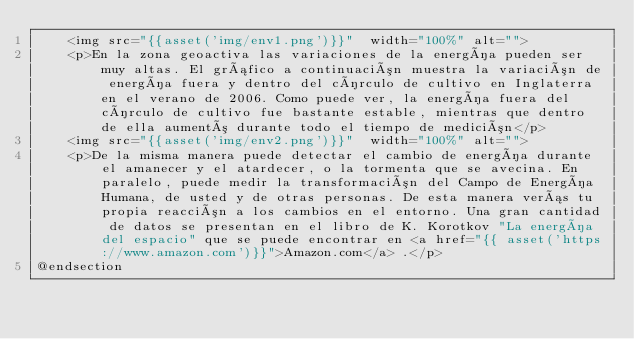Convert code to text. <code><loc_0><loc_0><loc_500><loc_500><_PHP_>    <img src="{{asset('img/env1.png')}}"  width="100%" alt="">
    <p>En la zona geoactiva las variaciones de la energía pueden ser muy altas. El gráfico a continuación muestra la variación de energía fuera y dentro del círculo de cultivo en Inglaterra en el verano de 2006. Como puede ver, la energía fuera del círculo de cultivo fue bastante estable, mientras que dentro de ella aumentó durante todo el tiempo de medición</p>
    <img src="{{asset('img/env2.png')}}"  width="100%" alt="">
    <p>De la misma manera puede detectar el cambio de energía durante el amanecer y el atardecer, o la tormenta que se avecina. En paralelo, puede medir la transformación del Campo de Energía Humana, de usted y de otras personas. De esta manera verás tu propia reacción a los cambios en el entorno. Una gran cantidad de datos se presentan en el libro de K. Korotkov "La energía del espacio" que se puede encontrar en <a href="{{ asset('https://www.amazon.com')}}">Amazon.com</a> .</p>
@endsection

</code> 